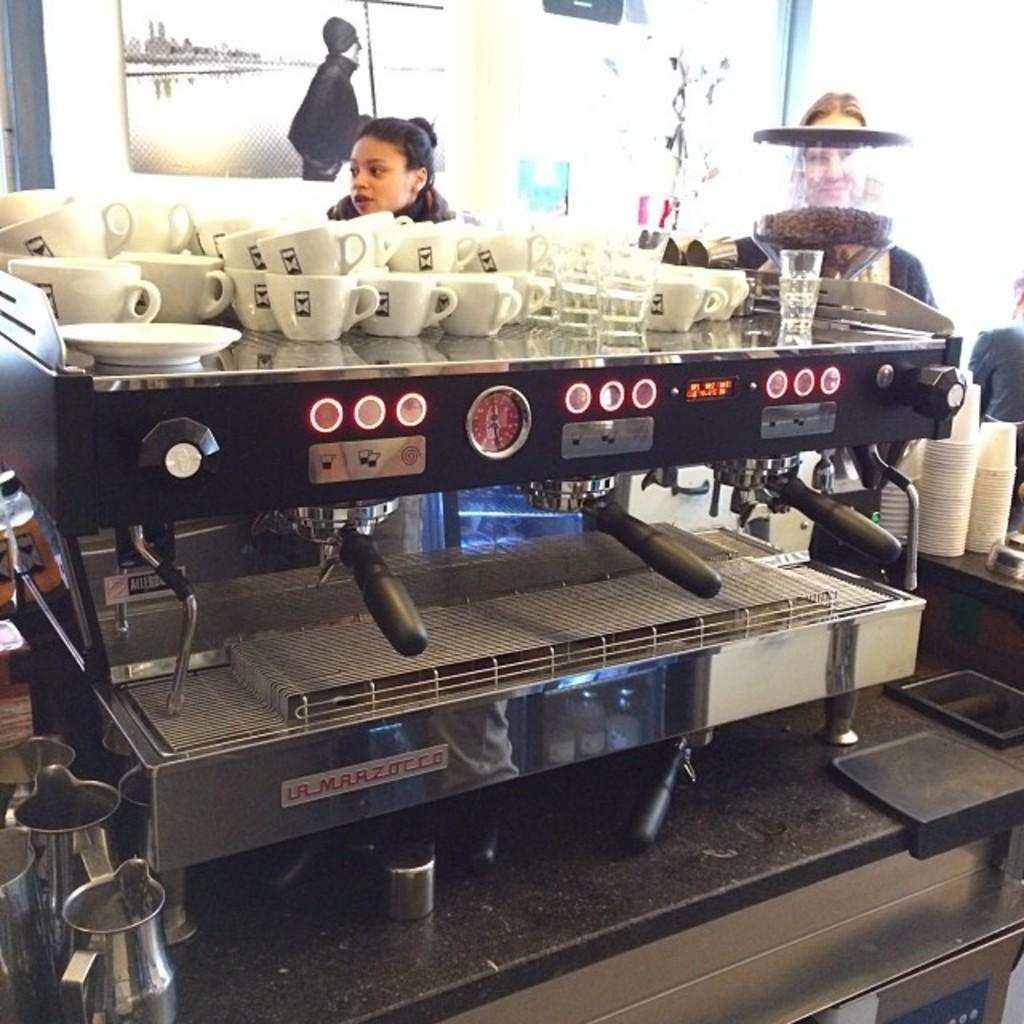<image>
Relay a brief, clear account of the picture shown. People are waiting in line behind a La Marzocco espresso machine. 